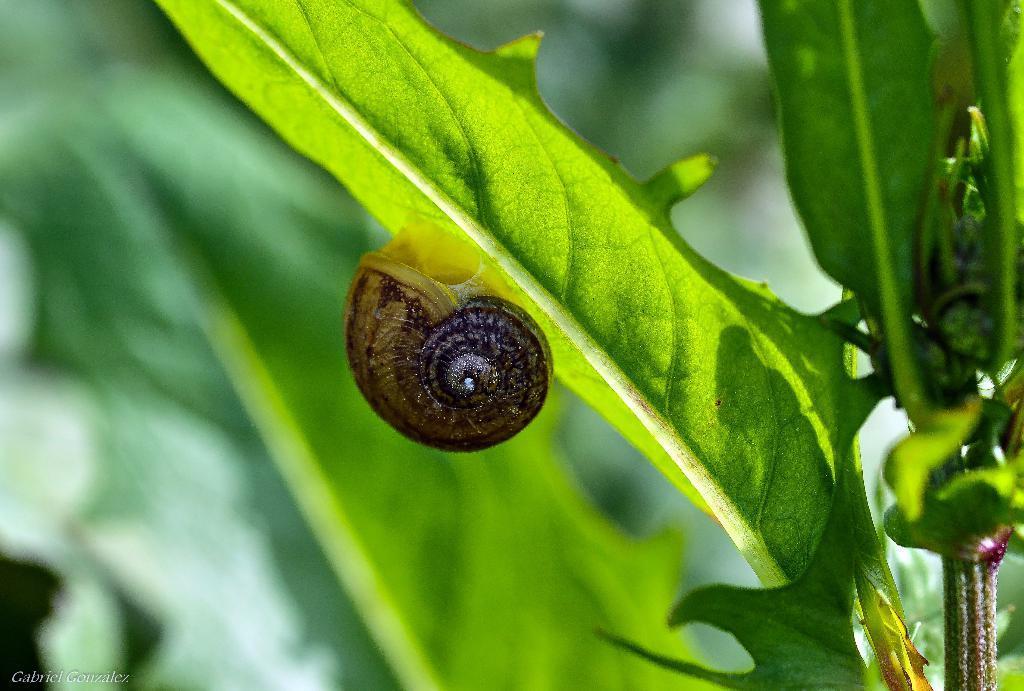How would you summarize this image in a sentence or two? In this image there is a snail on a leaf in the background it is blurred. 